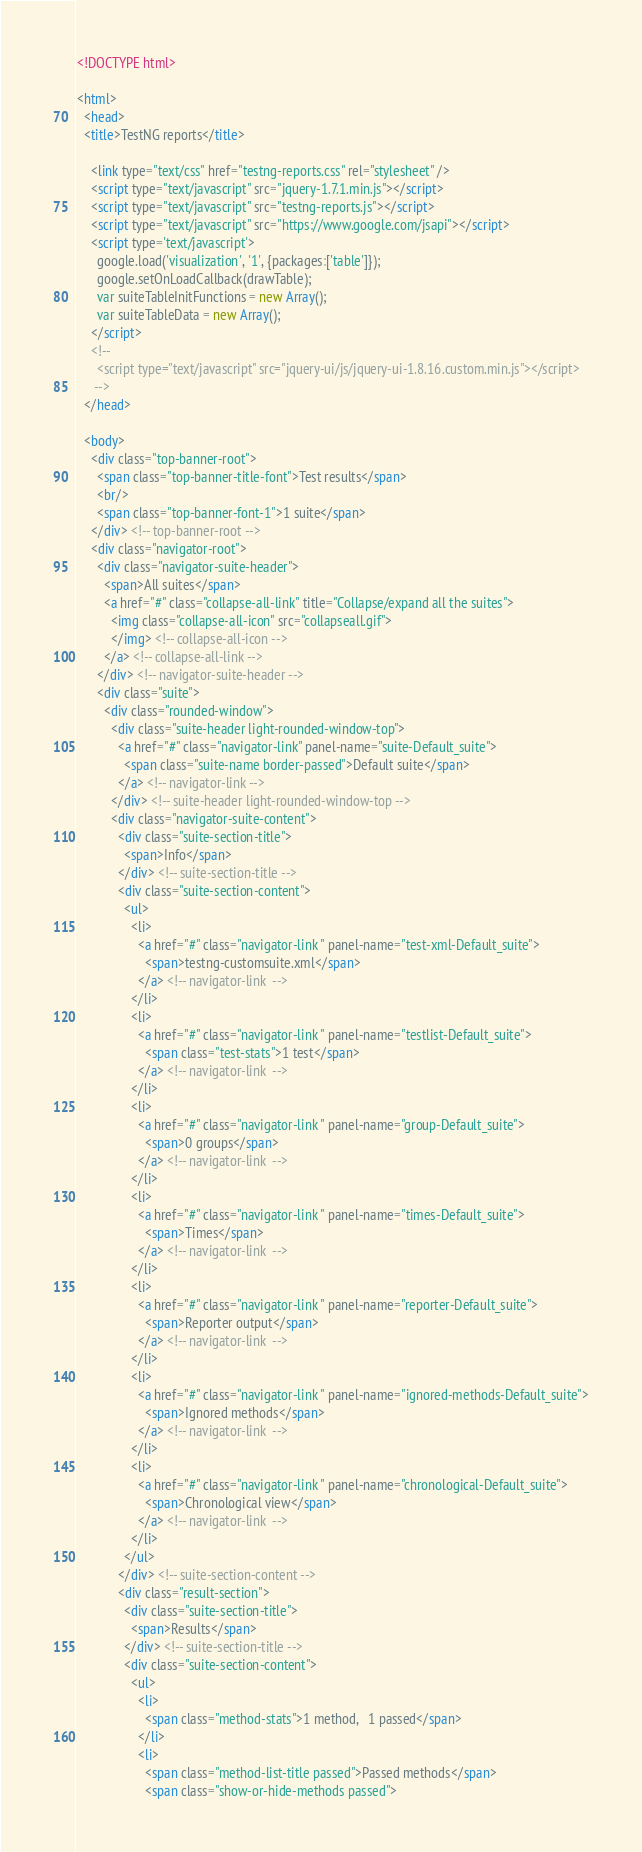Convert code to text. <code><loc_0><loc_0><loc_500><loc_500><_HTML_><!DOCTYPE html>

<html>
  <head>
  <title>TestNG reports</title>

    <link type="text/css" href="testng-reports.css" rel="stylesheet" />  
    <script type="text/javascript" src="jquery-1.7.1.min.js"></script>
    <script type="text/javascript" src="testng-reports.js"></script>
    <script type="text/javascript" src="https://www.google.com/jsapi"></script>
    <script type='text/javascript'>
      google.load('visualization', '1', {packages:['table']});
      google.setOnLoadCallback(drawTable);
      var suiteTableInitFunctions = new Array();
      var suiteTableData = new Array();
    </script>
    <!--
      <script type="text/javascript" src="jquery-ui/js/jquery-ui-1.8.16.custom.min.js"></script>
     -->
  </head>

  <body>
    <div class="top-banner-root">
      <span class="top-banner-title-font">Test results</span>
      <br/>
      <span class="top-banner-font-1">1 suite</span>
    </div> <!-- top-banner-root -->
    <div class="navigator-root">
      <div class="navigator-suite-header">
        <span>All suites</span>
        <a href="#" class="collapse-all-link" title="Collapse/expand all the suites">
          <img class="collapse-all-icon" src="collapseall.gif">
          </img> <!-- collapse-all-icon -->
        </a> <!-- collapse-all-link -->
      </div> <!-- navigator-suite-header -->
      <div class="suite">
        <div class="rounded-window">
          <div class="suite-header light-rounded-window-top">
            <a href="#" class="navigator-link" panel-name="suite-Default_suite">
              <span class="suite-name border-passed">Default suite</span>
            </a> <!-- navigator-link -->
          </div> <!-- suite-header light-rounded-window-top -->
          <div class="navigator-suite-content">
            <div class="suite-section-title">
              <span>Info</span>
            </div> <!-- suite-section-title -->
            <div class="suite-section-content">
              <ul>
                <li>
                  <a href="#" class="navigator-link " panel-name="test-xml-Default_suite">
                    <span>testng-customsuite.xml</span>
                  </a> <!-- navigator-link  -->
                </li>
                <li>
                  <a href="#" class="navigator-link " panel-name="testlist-Default_suite">
                    <span class="test-stats">1 test</span>
                  </a> <!-- navigator-link  -->
                </li>
                <li>
                  <a href="#" class="navigator-link " panel-name="group-Default_suite">
                    <span>0 groups</span>
                  </a> <!-- navigator-link  -->
                </li>
                <li>
                  <a href="#" class="navigator-link " panel-name="times-Default_suite">
                    <span>Times</span>
                  </a> <!-- navigator-link  -->
                </li>
                <li>
                  <a href="#" class="navigator-link " panel-name="reporter-Default_suite">
                    <span>Reporter output</span>
                  </a> <!-- navigator-link  -->
                </li>
                <li>
                  <a href="#" class="navigator-link " panel-name="ignored-methods-Default_suite">
                    <span>Ignored methods</span>
                  </a> <!-- navigator-link  -->
                </li>
                <li>
                  <a href="#" class="navigator-link " panel-name="chronological-Default_suite">
                    <span>Chronological view</span>
                  </a> <!-- navigator-link  -->
                </li>
              </ul>
            </div> <!-- suite-section-content -->
            <div class="result-section">
              <div class="suite-section-title">
                <span>Results</span>
              </div> <!-- suite-section-title -->
              <div class="suite-section-content">
                <ul>
                  <li>
                    <span class="method-stats">1 method,   1 passed</span>
                  </li>
                  <li>
                    <span class="method-list-title passed">Passed methods</span>
                    <span class="show-or-hide-methods passed"></code> 